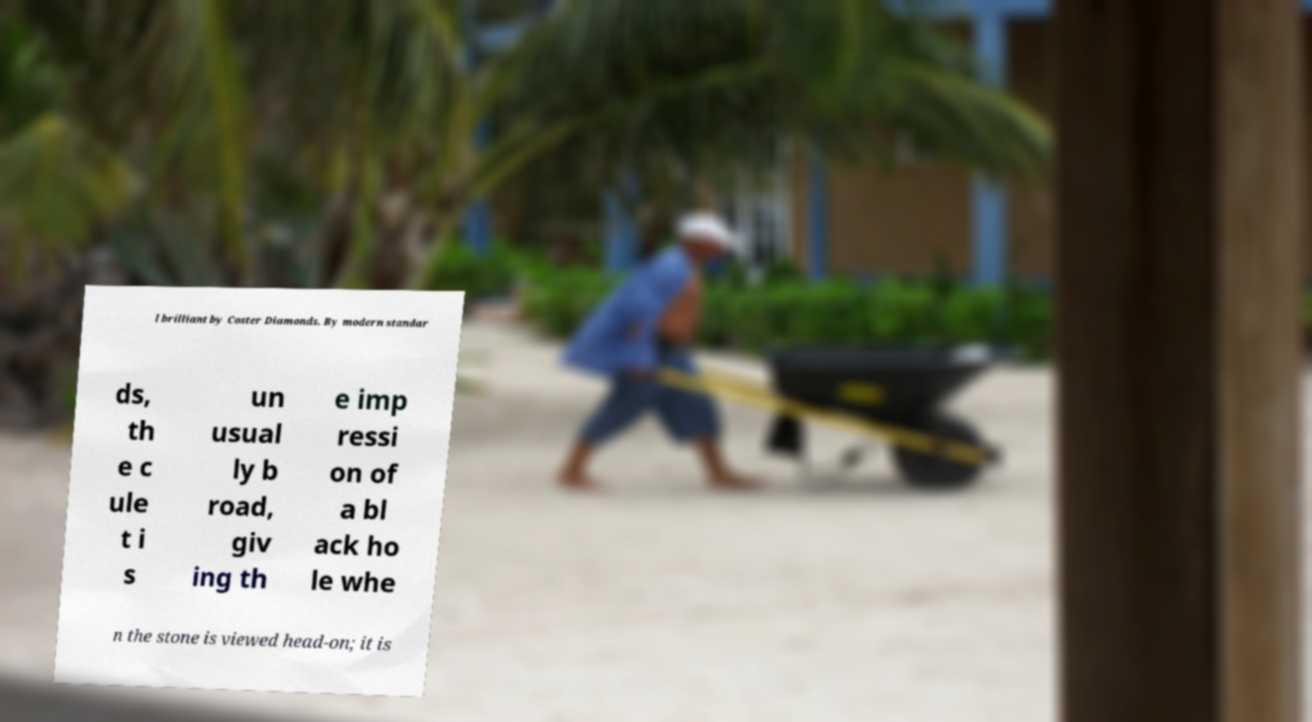I need the written content from this picture converted into text. Can you do that? l brilliant by Coster Diamonds. By modern standar ds, th e c ule t i s un usual ly b road, giv ing th e imp ressi on of a bl ack ho le whe n the stone is viewed head-on; it is 